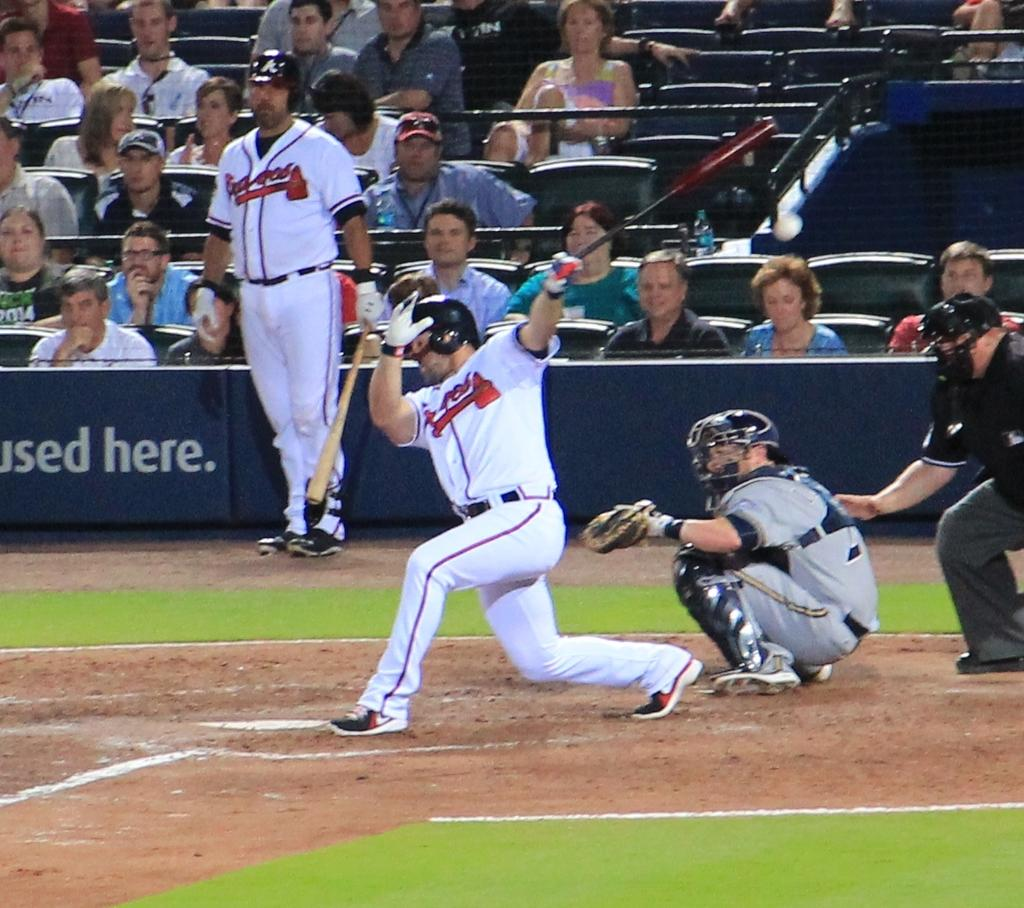<image>
Render a clear and concise summary of the photo. A partially visible ballpark ad says something is Used Here. 